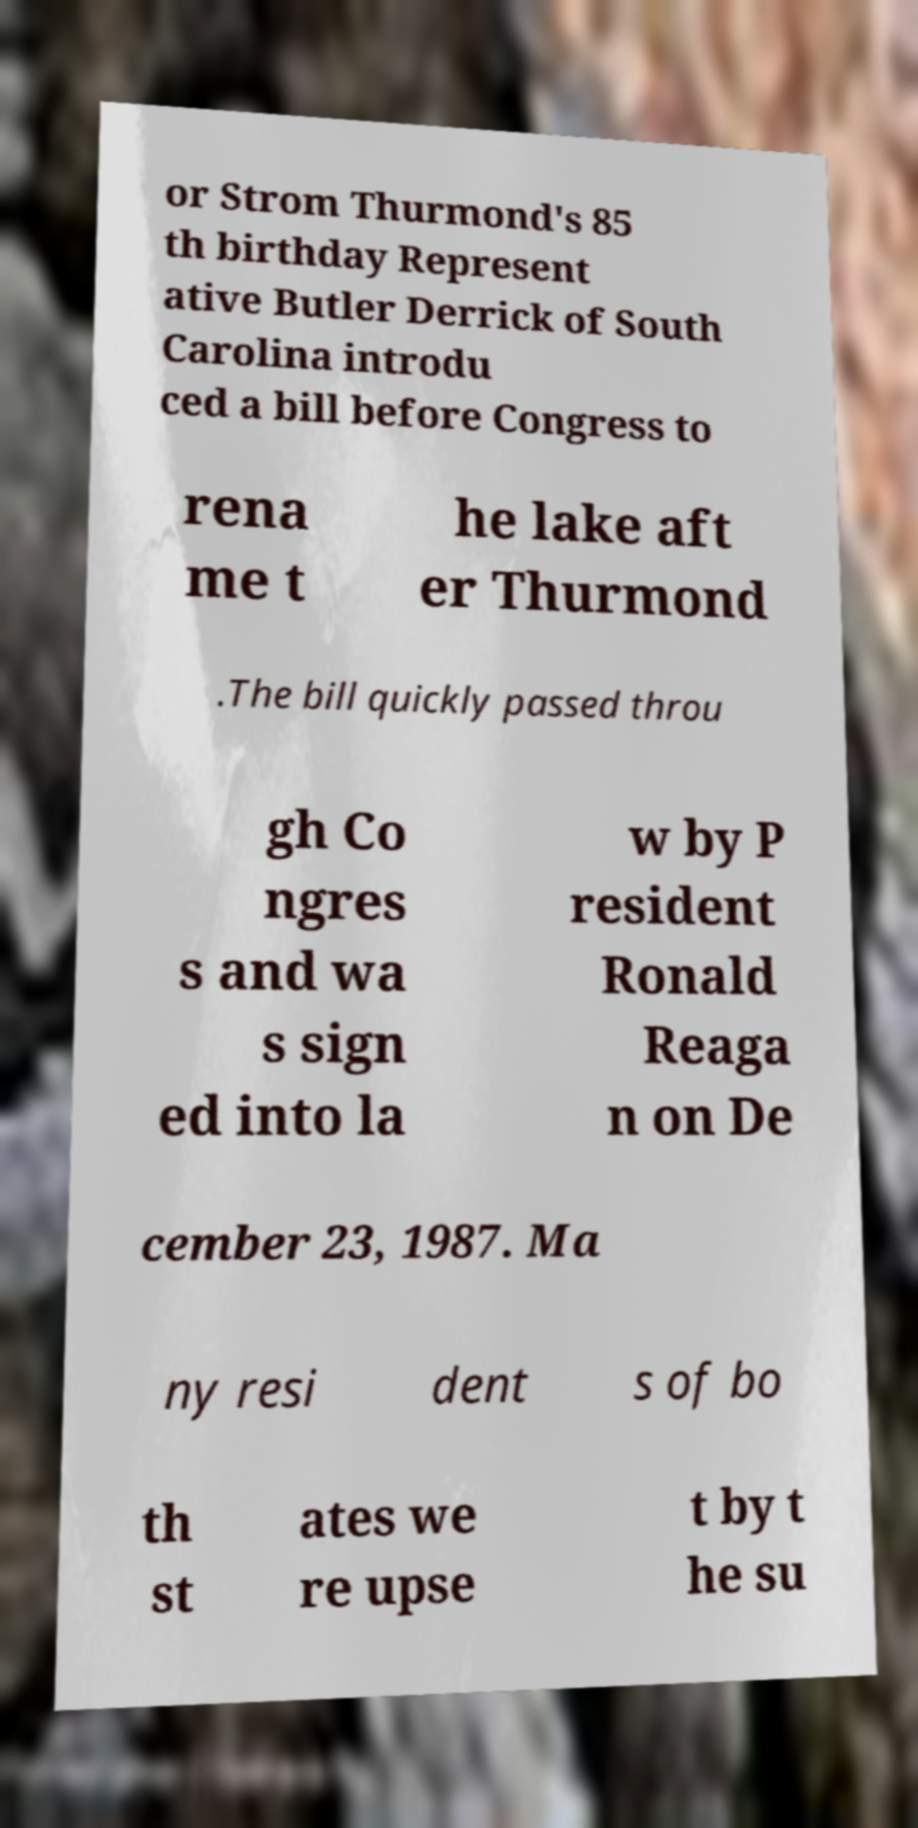For documentation purposes, I need the text within this image transcribed. Could you provide that? or Strom Thurmond's 85 th birthday Represent ative Butler Derrick of South Carolina introdu ced a bill before Congress to rena me t he lake aft er Thurmond .The bill quickly passed throu gh Co ngres s and wa s sign ed into la w by P resident Ronald Reaga n on De cember 23, 1987. Ma ny resi dent s of bo th st ates we re upse t by t he su 